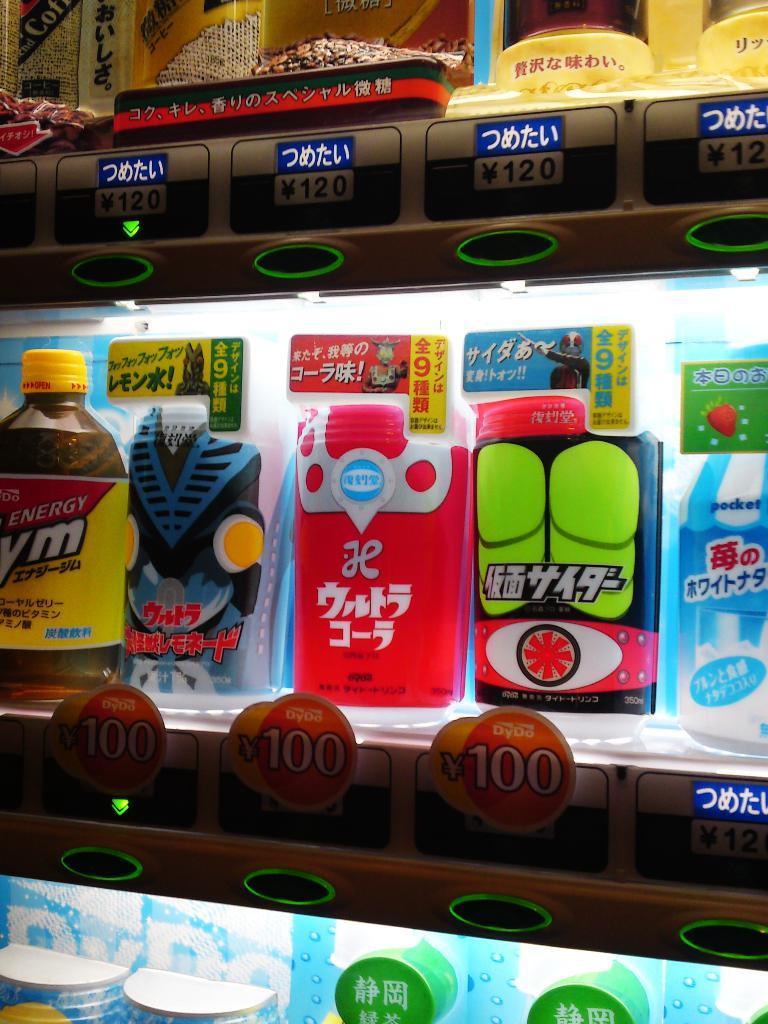Describe this image in one or two sentences. In the picture we can see a super market racks with some items and price tags to the racks and lights to the racks focused on the items. 